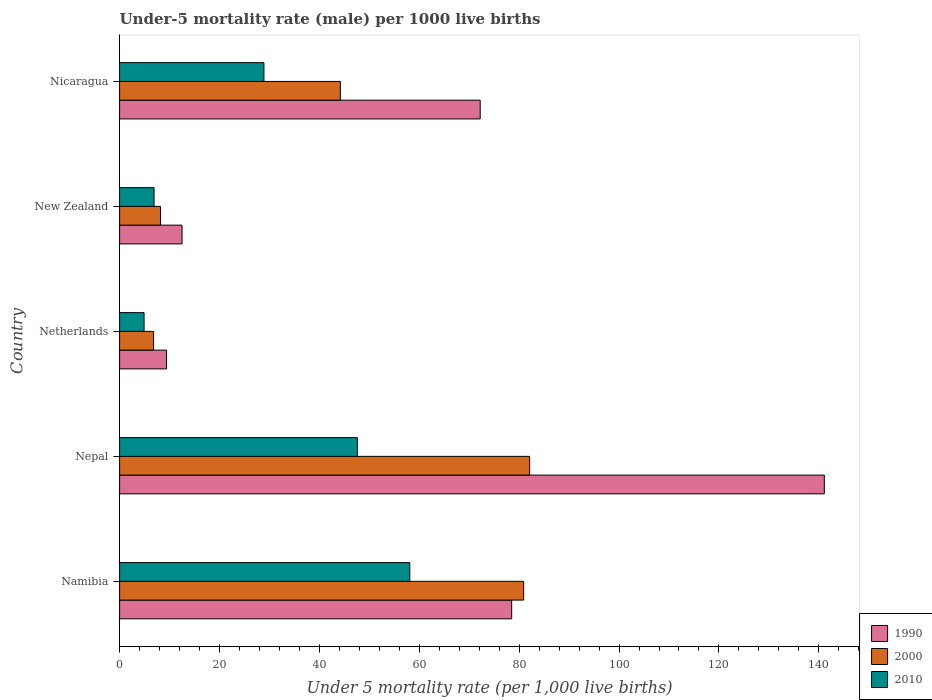What is the label of the 5th group of bars from the top?
Offer a terse response. Namibia. In how many cases, is the number of bars for a given country not equal to the number of legend labels?
Give a very brief answer. 0. What is the under-five mortality rate in 2000 in Nicaragua?
Your answer should be very brief. 44.2. Across all countries, what is the maximum under-five mortality rate in 1990?
Your answer should be very brief. 141.1. Across all countries, what is the minimum under-five mortality rate in 2010?
Keep it short and to the point. 4.9. In which country was the under-five mortality rate in 1990 maximum?
Offer a very short reply. Nepal. What is the total under-five mortality rate in 1990 in the graph?
Ensure brevity in your answer.  313.7. What is the difference between the under-five mortality rate in 2010 in Namibia and that in Nicaragua?
Provide a short and direct response. 29.2. What is the difference between the under-five mortality rate in 1990 in New Zealand and the under-five mortality rate in 2010 in Namibia?
Provide a short and direct response. -45.6. What is the average under-five mortality rate in 2010 per country?
Give a very brief answer. 29.28. What is the difference between the under-five mortality rate in 2000 and under-five mortality rate in 2010 in Namibia?
Offer a terse response. 22.8. In how many countries, is the under-five mortality rate in 2000 greater than 8 ?
Offer a very short reply. 4. What is the ratio of the under-five mortality rate in 2000 in Nepal to that in Netherlands?
Keep it short and to the point. 12.07. What is the difference between the highest and the second highest under-five mortality rate in 2000?
Give a very brief answer. 1.2. What is the difference between the highest and the lowest under-five mortality rate in 2010?
Offer a very short reply. 53.2. Is the sum of the under-five mortality rate in 2000 in Namibia and Netherlands greater than the maximum under-five mortality rate in 2010 across all countries?
Your answer should be compact. Yes. What does the 3rd bar from the bottom in Netherlands represents?
Your response must be concise. 2010. Are all the bars in the graph horizontal?
Your answer should be compact. Yes. How many countries are there in the graph?
Offer a very short reply. 5. What is the difference between two consecutive major ticks on the X-axis?
Your answer should be very brief. 20. Are the values on the major ticks of X-axis written in scientific E-notation?
Ensure brevity in your answer.  No. Does the graph contain any zero values?
Make the answer very short. No. Does the graph contain grids?
Offer a terse response. No. Where does the legend appear in the graph?
Give a very brief answer. Bottom right. How many legend labels are there?
Your answer should be compact. 3. What is the title of the graph?
Give a very brief answer. Under-5 mortality rate (male) per 1000 live births. What is the label or title of the X-axis?
Offer a very short reply. Under 5 mortality rate (per 1,0 live births). What is the Under 5 mortality rate (per 1,000 live births) of 1990 in Namibia?
Make the answer very short. 78.5. What is the Under 5 mortality rate (per 1,000 live births) in 2000 in Namibia?
Provide a short and direct response. 80.9. What is the Under 5 mortality rate (per 1,000 live births) of 2010 in Namibia?
Keep it short and to the point. 58.1. What is the Under 5 mortality rate (per 1,000 live births) of 1990 in Nepal?
Your answer should be very brief. 141.1. What is the Under 5 mortality rate (per 1,000 live births) in 2000 in Nepal?
Make the answer very short. 82.1. What is the Under 5 mortality rate (per 1,000 live births) of 2010 in Nepal?
Offer a very short reply. 47.6. What is the Under 5 mortality rate (per 1,000 live births) in 2010 in New Zealand?
Keep it short and to the point. 6.9. What is the Under 5 mortality rate (per 1,000 live births) of 1990 in Nicaragua?
Provide a succinct answer. 72.2. What is the Under 5 mortality rate (per 1,000 live births) in 2000 in Nicaragua?
Give a very brief answer. 44.2. What is the Under 5 mortality rate (per 1,000 live births) in 2010 in Nicaragua?
Provide a succinct answer. 28.9. Across all countries, what is the maximum Under 5 mortality rate (per 1,000 live births) of 1990?
Provide a succinct answer. 141.1. Across all countries, what is the maximum Under 5 mortality rate (per 1,000 live births) of 2000?
Keep it short and to the point. 82.1. Across all countries, what is the maximum Under 5 mortality rate (per 1,000 live births) in 2010?
Your answer should be very brief. 58.1. Across all countries, what is the minimum Under 5 mortality rate (per 1,000 live births) of 2010?
Keep it short and to the point. 4.9. What is the total Under 5 mortality rate (per 1,000 live births) in 1990 in the graph?
Your answer should be compact. 313.7. What is the total Under 5 mortality rate (per 1,000 live births) of 2000 in the graph?
Your response must be concise. 222.2. What is the total Under 5 mortality rate (per 1,000 live births) of 2010 in the graph?
Make the answer very short. 146.4. What is the difference between the Under 5 mortality rate (per 1,000 live births) of 1990 in Namibia and that in Nepal?
Ensure brevity in your answer.  -62.6. What is the difference between the Under 5 mortality rate (per 1,000 live births) in 2000 in Namibia and that in Nepal?
Your answer should be very brief. -1.2. What is the difference between the Under 5 mortality rate (per 1,000 live births) of 1990 in Namibia and that in Netherlands?
Provide a succinct answer. 69.1. What is the difference between the Under 5 mortality rate (per 1,000 live births) of 2000 in Namibia and that in Netherlands?
Keep it short and to the point. 74.1. What is the difference between the Under 5 mortality rate (per 1,000 live births) of 2010 in Namibia and that in Netherlands?
Give a very brief answer. 53.2. What is the difference between the Under 5 mortality rate (per 1,000 live births) of 2000 in Namibia and that in New Zealand?
Your answer should be compact. 72.7. What is the difference between the Under 5 mortality rate (per 1,000 live births) of 2010 in Namibia and that in New Zealand?
Ensure brevity in your answer.  51.2. What is the difference between the Under 5 mortality rate (per 1,000 live births) in 1990 in Namibia and that in Nicaragua?
Offer a very short reply. 6.3. What is the difference between the Under 5 mortality rate (per 1,000 live births) in 2000 in Namibia and that in Nicaragua?
Your answer should be very brief. 36.7. What is the difference between the Under 5 mortality rate (per 1,000 live births) in 2010 in Namibia and that in Nicaragua?
Offer a terse response. 29.2. What is the difference between the Under 5 mortality rate (per 1,000 live births) of 1990 in Nepal and that in Netherlands?
Provide a succinct answer. 131.7. What is the difference between the Under 5 mortality rate (per 1,000 live births) in 2000 in Nepal and that in Netherlands?
Ensure brevity in your answer.  75.3. What is the difference between the Under 5 mortality rate (per 1,000 live births) of 2010 in Nepal and that in Netherlands?
Your answer should be very brief. 42.7. What is the difference between the Under 5 mortality rate (per 1,000 live births) in 1990 in Nepal and that in New Zealand?
Give a very brief answer. 128.6. What is the difference between the Under 5 mortality rate (per 1,000 live births) in 2000 in Nepal and that in New Zealand?
Your answer should be very brief. 73.9. What is the difference between the Under 5 mortality rate (per 1,000 live births) of 2010 in Nepal and that in New Zealand?
Offer a terse response. 40.7. What is the difference between the Under 5 mortality rate (per 1,000 live births) of 1990 in Nepal and that in Nicaragua?
Keep it short and to the point. 68.9. What is the difference between the Under 5 mortality rate (per 1,000 live births) of 2000 in Nepal and that in Nicaragua?
Make the answer very short. 37.9. What is the difference between the Under 5 mortality rate (per 1,000 live births) in 2000 in Netherlands and that in New Zealand?
Offer a very short reply. -1.4. What is the difference between the Under 5 mortality rate (per 1,000 live births) in 2010 in Netherlands and that in New Zealand?
Keep it short and to the point. -2. What is the difference between the Under 5 mortality rate (per 1,000 live births) in 1990 in Netherlands and that in Nicaragua?
Your answer should be compact. -62.8. What is the difference between the Under 5 mortality rate (per 1,000 live births) in 2000 in Netherlands and that in Nicaragua?
Give a very brief answer. -37.4. What is the difference between the Under 5 mortality rate (per 1,000 live births) of 1990 in New Zealand and that in Nicaragua?
Your answer should be very brief. -59.7. What is the difference between the Under 5 mortality rate (per 1,000 live births) of 2000 in New Zealand and that in Nicaragua?
Your answer should be compact. -36. What is the difference between the Under 5 mortality rate (per 1,000 live births) in 1990 in Namibia and the Under 5 mortality rate (per 1,000 live births) in 2010 in Nepal?
Offer a very short reply. 30.9. What is the difference between the Under 5 mortality rate (per 1,000 live births) in 2000 in Namibia and the Under 5 mortality rate (per 1,000 live births) in 2010 in Nepal?
Offer a terse response. 33.3. What is the difference between the Under 5 mortality rate (per 1,000 live births) in 1990 in Namibia and the Under 5 mortality rate (per 1,000 live births) in 2000 in Netherlands?
Your response must be concise. 71.7. What is the difference between the Under 5 mortality rate (per 1,000 live births) in 1990 in Namibia and the Under 5 mortality rate (per 1,000 live births) in 2010 in Netherlands?
Keep it short and to the point. 73.6. What is the difference between the Under 5 mortality rate (per 1,000 live births) in 2000 in Namibia and the Under 5 mortality rate (per 1,000 live births) in 2010 in Netherlands?
Provide a short and direct response. 76. What is the difference between the Under 5 mortality rate (per 1,000 live births) in 1990 in Namibia and the Under 5 mortality rate (per 1,000 live births) in 2000 in New Zealand?
Give a very brief answer. 70.3. What is the difference between the Under 5 mortality rate (per 1,000 live births) in 1990 in Namibia and the Under 5 mortality rate (per 1,000 live births) in 2010 in New Zealand?
Keep it short and to the point. 71.6. What is the difference between the Under 5 mortality rate (per 1,000 live births) of 2000 in Namibia and the Under 5 mortality rate (per 1,000 live births) of 2010 in New Zealand?
Your answer should be compact. 74. What is the difference between the Under 5 mortality rate (per 1,000 live births) of 1990 in Namibia and the Under 5 mortality rate (per 1,000 live births) of 2000 in Nicaragua?
Make the answer very short. 34.3. What is the difference between the Under 5 mortality rate (per 1,000 live births) of 1990 in Namibia and the Under 5 mortality rate (per 1,000 live births) of 2010 in Nicaragua?
Your response must be concise. 49.6. What is the difference between the Under 5 mortality rate (per 1,000 live births) in 2000 in Namibia and the Under 5 mortality rate (per 1,000 live births) in 2010 in Nicaragua?
Give a very brief answer. 52. What is the difference between the Under 5 mortality rate (per 1,000 live births) in 1990 in Nepal and the Under 5 mortality rate (per 1,000 live births) in 2000 in Netherlands?
Keep it short and to the point. 134.3. What is the difference between the Under 5 mortality rate (per 1,000 live births) of 1990 in Nepal and the Under 5 mortality rate (per 1,000 live births) of 2010 in Netherlands?
Give a very brief answer. 136.2. What is the difference between the Under 5 mortality rate (per 1,000 live births) in 2000 in Nepal and the Under 5 mortality rate (per 1,000 live births) in 2010 in Netherlands?
Your answer should be compact. 77.2. What is the difference between the Under 5 mortality rate (per 1,000 live births) in 1990 in Nepal and the Under 5 mortality rate (per 1,000 live births) in 2000 in New Zealand?
Offer a terse response. 132.9. What is the difference between the Under 5 mortality rate (per 1,000 live births) in 1990 in Nepal and the Under 5 mortality rate (per 1,000 live births) in 2010 in New Zealand?
Give a very brief answer. 134.2. What is the difference between the Under 5 mortality rate (per 1,000 live births) of 2000 in Nepal and the Under 5 mortality rate (per 1,000 live births) of 2010 in New Zealand?
Give a very brief answer. 75.2. What is the difference between the Under 5 mortality rate (per 1,000 live births) in 1990 in Nepal and the Under 5 mortality rate (per 1,000 live births) in 2000 in Nicaragua?
Offer a very short reply. 96.9. What is the difference between the Under 5 mortality rate (per 1,000 live births) of 1990 in Nepal and the Under 5 mortality rate (per 1,000 live births) of 2010 in Nicaragua?
Offer a terse response. 112.2. What is the difference between the Under 5 mortality rate (per 1,000 live births) of 2000 in Nepal and the Under 5 mortality rate (per 1,000 live births) of 2010 in Nicaragua?
Keep it short and to the point. 53.2. What is the difference between the Under 5 mortality rate (per 1,000 live births) of 1990 in Netherlands and the Under 5 mortality rate (per 1,000 live births) of 2000 in Nicaragua?
Your answer should be very brief. -34.8. What is the difference between the Under 5 mortality rate (per 1,000 live births) of 1990 in Netherlands and the Under 5 mortality rate (per 1,000 live births) of 2010 in Nicaragua?
Your response must be concise. -19.5. What is the difference between the Under 5 mortality rate (per 1,000 live births) in 2000 in Netherlands and the Under 5 mortality rate (per 1,000 live births) in 2010 in Nicaragua?
Offer a terse response. -22.1. What is the difference between the Under 5 mortality rate (per 1,000 live births) in 1990 in New Zealand and the Under 5 mortality rate (per 1,000 live births) in 2000 in Nicaragua?
Your answer should be very brief. -31.7. What is the difference between the Under 5 mortality rate (per 1,000 live births) of 1990 in New Zealand and the Under 5 mortality rate (per 1,000 live births) of 2010 in Nicaragua?
Your answer should be very brief. -16.4. What is the difference between the Under 5 mortality rate (per 1,000 live births) in 2000 in New Zealand and the Under 5 mortality rate (per 1,000 live births) in 2010 in Nicaragua?
Ensure brevity in your answer.  -20.7. What is the average Under 5 mortality rate (per 1,000 live births) of 1990 per country?
Give a very brief answer. 62.74. What is the average Under 5 mortality rate (per 1,000 live births) in 2000 per country?
Your response must be concise. 44.44. What is the average Under 5 mortality rate (per 1,000 live births) of 2010 per country?
Provide a succinct answer. 29.28. What is the difference between the Under 5 mortality rate (per 1,000 live births) of 1990 and Under 5 mortality rate (per 1,000 live births) of 2010 in Namibia?
Your response must be concise. 20.4. What is the difference between the Under 5 mortality rate (per 1,000 live births) of 2000 and Under 5 mortality rate (per 1,000 live births) of 2010 in Namibia?
Provide a succinct answer. 22.8. What is the difference between the Under 5 mortality rate (per 1,000 live births) of 1990 and Under 5 mortality rate (per 1,000 live births) of 2010 in Nepal?
Provide a succinct answer. 93.5. What is the difference between the Under 5 mortality rate (per 1,000 live births) in 2000 and Under 5 mortality rate (per 1,000 live births) in 2010 in Nepal?
Keep it short and to the point. 34.5. What is the difference between the Under 5 mortality rate (per 1,000 live births) of 1990 and Under 5 mortality rate (per 1,000 live births) of 2010 in Netherlands?
Ensure brevity in your answer.  4.5. What is the difference between the Under 5 mortality rate (per 1,000 live births) of 2000 and Under 5 mortality rate (per 1,000 live births) of 2010 in Netherlands?
Keep it short and to the point. 1.9. What is the difference between the Under 5 mortality rate (per 1,000 live births) of 1990 and Under 5 mortality rate (per 1,000 live births) of 2000 in New Zealand?
Provide a succinct answer. 4.3. What is the difference between the Under 5 mortality rate (per 1,000 live births) of 1990 and Under 5 mortality rate (per 1,000 live births) of 2010 in New Zealand?
Offer a terse response. 5.6. What is the difference between the Under 5 mortality rate (per 1,000 live births) of 2000 and Under 5 mortality rate (per 1,000 live births) of 2010 in New Zealand?
Your answer should be compact. 1.3. What is the difference between the Under 5 mortality rate (per 1,000 live births) of 1990 and Under 5 mortality rate (per 1,000 live births) of 2010 in Nicaragua?
Provide a short and direct response. 43.3. What is the difference between the Under 5 mortality rate (per 1,000 live births) in 2000 and Under 5 mortality rate (per 1,000 live births) in 2010 in Nicaragua?
Keep it short and to the point. 15.3. What is the ratio of the Under 5 mortality rate (per 1,000 live births) in 1990 in Namibia to that in Nepal?
Keep it short and to the point. 0.56. What is the ratio of the Under 5 mortality rate (per 1,000 live births) in 2000 in Namibia to that in Nepal?
Offer a terse response. 0.99. What is the ratio of the Under 5 mortality rate (per 1,000 live births) in 2010 in Namibia to that in Nepal?
Make the answer very short. 1.22. What is the ratio of the Under 5 mortality rate (per 1,000 live births) in 1990 in Namibia to that in Netherlands?
Give a very brief answer. 8.35. What is the ratio of the Under 5 mortality rate (per 1,000 live births) of 2000 in Namibia to that in Netherlands?
Your response must be concise. 11.9. What is the ratio of the Under 5 mortality rate (per 1,000 live births) of 2010 in Namibia to that in Netherlands?
Offer a very short reply. 11.86. What is the ratio of the Under 5 mortality rate (per 1,000 live births) of 1990 in Namibia to that in New Zealand?
Your response must be concise. 6.28. What is the ratio of the Under 5 mortality rate (per 1,000 live births) in 2000 in Namibia to that in New Zealand?
Provide a short and direct response. 9.87. What is the ratio of the Under 5 mortality rate (per 1,000 live births) in 2010 in Namibia to that in New Zealand?
Your response must be concise. 8.42. What is the ratio of the Under 5 mortality rate (per 1,000 live births) of 1990 in Namibia to that in Nicaragua?
Keep it short and to the point. 1.09. What is the ratio of the Under 5 mortality rate (per 1,000 live births) of 2000 in Namibia to that in Nicaragua?
Keep it short and to the point. 1.83. What is the ratio of the Under 5 mortality rate (per 1,000 live births) of 2010 in Namibia to that in Nicaragua?
Provide a short and direct response. 2.01. What is the ratio of the Under 5 mortality rate (per 1,000 live births) of 1990 in Nepal to that in Netherlands?
Your answer should be very brief. 15.01. What is the ratio of the Under 5 mortality rate (per 1,000 live births) of 2000 in Nepal to that in Netherlands?
Provide a short and direct response. 12.07. What is the ratio of the Under 5 mortality rate (per 1,000 live births) in 2010 in Nepal to that in Netherlands?
Your answer should be compact. 9.71. What is the ratio of the Under 5 mortality rate (per 1,000 live births) of 1990 in Nepal to that in New Zealand?
Offer a terse response. 11.29. What is the ratio of the Under 5 mortality rate (per 1,000 live births) of 2000 in Nepal to that in New Zealand?
Offer a terse response. 10.01. What is the ratio of the Under 5 mortality rate (per 1,000 live births) in 2010 in Nepal to that in New Zealand?
Provide a short and direct response. 6.9. What is the ratio of the Under 5 mortality rate (per 1,000 live births) of 1990 in Nepal to that in Nicaragua?
Your response must be concise. 1.95. What is the ratio of the Under 5 mortality rate (per 1,000 live births) of 2000 in Nepal to that in Nicaragua?
Make the answer very short. 1.86. What is the ratio of the Under 5 mortality rate (per 1,000 live births) in 2010 in Nepal to that in Nicaragua?
Make the answer very short. 1.65. What is the ratio of the Under 5 mortality rate (per 1,000 live births) in 1990 in Netherlands to that in New Zealand?
Provide a succinct answer. 0.75. What is the ratio of the Under 5 mortality rate (per 1,000 live births) in 2000 in Netherlands to that in New Zealand?
Offer a terse response. 0.83. What is the ratio of the Under 5 mortality rate (per 1,000 live births) of 2010 in Netherlands to that in New Zealand?
Offer a terse response. 0.71. What is the ratio of the Under 5 mortality rate (per 1,000 live births) of 1990 in Netherlands to that in Nicaragua?
Ensure brevity in your answer.  0.13. What is the ratio of the Under 5 mortality rate (per 1,000 live births) in 2000 in Netherlands to that in Nicaragua?
Offer a terse response. 0.15. What is the ratio of the Under 5 mortality rate (per 1,000 live births) of 2010 in Netherlands to that in Nicaragua?
Your answer should be compact. 0.17. What is the ratio of the Under 5 mortality rate (per 1,000 live births) in 1990 in New Zealand to that in Nicaragua?
Provide a succinct answer. 0.17. What is the ratio of the Under 5 mortality rate (per 1,000 live births) of 2000 in New Zealand to that in Nicaragua?
Keep it short and to the point. 0.19. What is the ratio of the Under 5 mortality rate (per 1,000 live births) in 2010 in New Zealand to that in Nicaragua?
Provide a succinct answer. 0.24. What is the difference between the highest and the second highest Under 5 mortality rate (per 1,000 live births) of 1990?
Keep it short and to the point. 62.6. What is the difference between the highest and the lowest Under 5 mortality rate (per 1,000 live births) of 1990?
Your answer should be very brief. 131.7. What is the difference between the highest and the lowest Under 5 mortality rate (per 1,000 live births) of 2000?
Your response must be concise. 75.3. What is the difference between the highest and the lowest Under 5 mortality rate (per 1,000 live births) in 2010?
Keep it short and to the point. 53.2. 